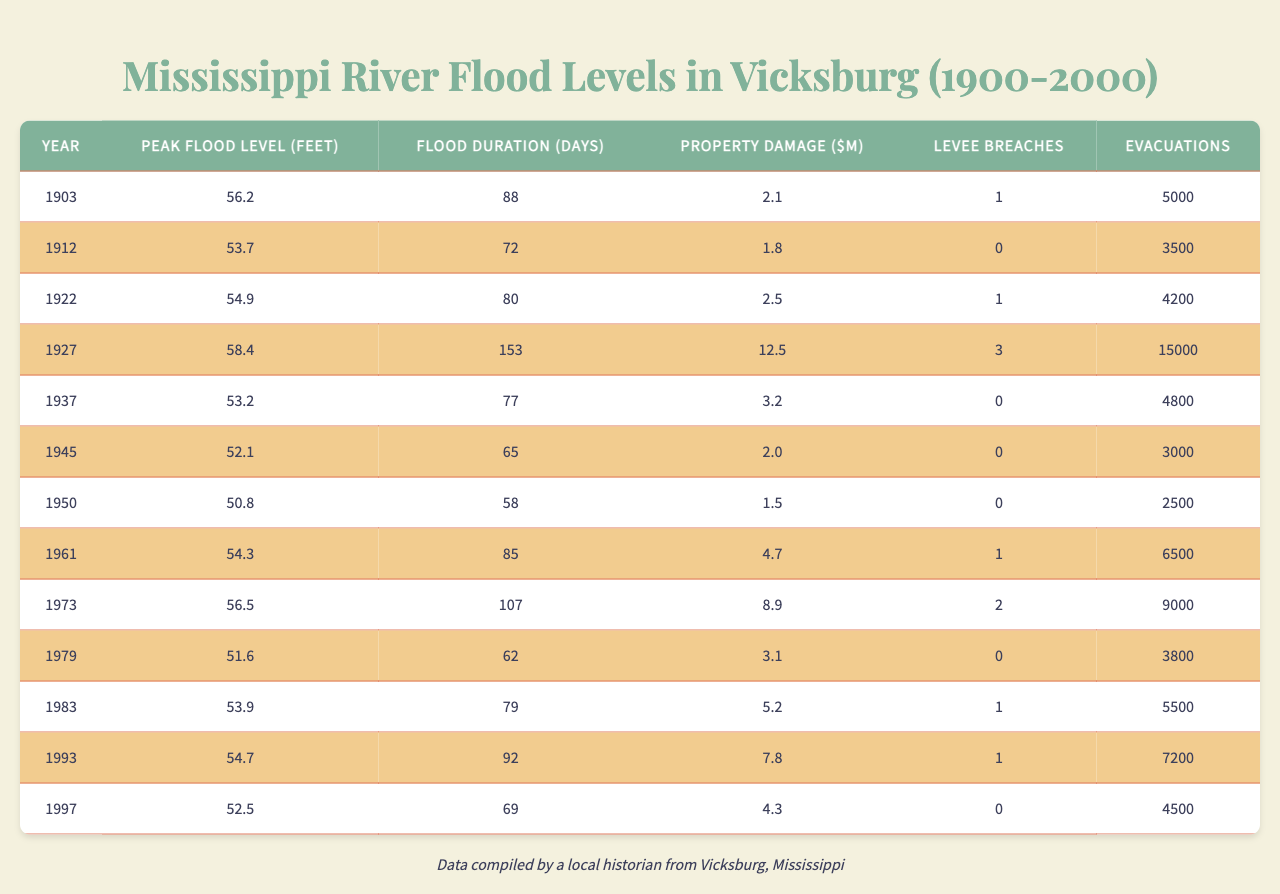What was the peak flood level in Vicksburg in 1927? According to the table, the peak flood level listed for the year 1927 is 58.4 feet.
Answer: 58.4 feet How many days did the flood last in 1950? The flood duration for the year 1950 is provided in the table as 58 days.
Answer: 58 days Which year experienced the most property damage and how much was it? The year with the highest property damage is 1927, with damage amounting to $12.5 million.
Answer: 1927, $12.5 million Were there any evacuations in 1945? The table shows that there were 3,000 evacuations in 1945.
Answer: Yes What is the average peak flood level from 1903 to 1997? To find the average peak flood level, sum the levels (56.2 + 53.7 + 54.9 + 58.4 + 53.2 + 52.1 + 50.8 + 54.3 + 56.5 + 51.6 + 53.9 + 54.7 + 52.5) which equals  658.2 feet, and divide by 13 years (658.2 / 13) to get approximately 50.64 feet.
Answer: 50.64 feet In how many years did the flood duration exceed 80 days? By checking the table, the flood durations that exceed 80 days occurred in 1927 (153 days), 1961 (85 days), 1973 (107 days), 1983 (79 days) and 1993 (92 days), totaling 5 occurrences. Therefore, there are three years that exceed 80 days.
Answer: 4 years What was the peak flood level in 1993 compared to 2000, and which is higher? The peak flood level in the table for 1993 is 54.7 feet, but there is no data for 2000. However, there was a flood in 1997 with a peak of 52.5 feet, thus 1993 is higher compared to 1997.
Answer: 1993 is higher Was the number of levee breaches higher in 1922 or 1983? According to the table, there were 1 levee breach in 1922 and 1 levee breach in 1983, so they have the same number of breaches.
Answer: They are equal What is the total property damage from floods in Vicksburg over these years? Total property damage can be calculated by summing the property damage values ($2.1 + $1.8 + $2.5 + $12.5 + $3.2 + $2.0 + $1.5 + $4.7 + $8.9 + $3.1 + $5.2 + $7.8 + $4.3), which equals $56.6 million.
Answer: $56.6 million In which year did the highest number of evacuations occur? The table shows that the highest number of evacuations occurred in 1927, with 15,000 evacuations.
Answer: 1927 How does the number of levee breaches compare between the years 1973 and 1993? In 1973, the number of levee breaches was 2, and in 1993, it was 1, indicating more breaches in 1973 than in 1993.
Answer: More in 1973 